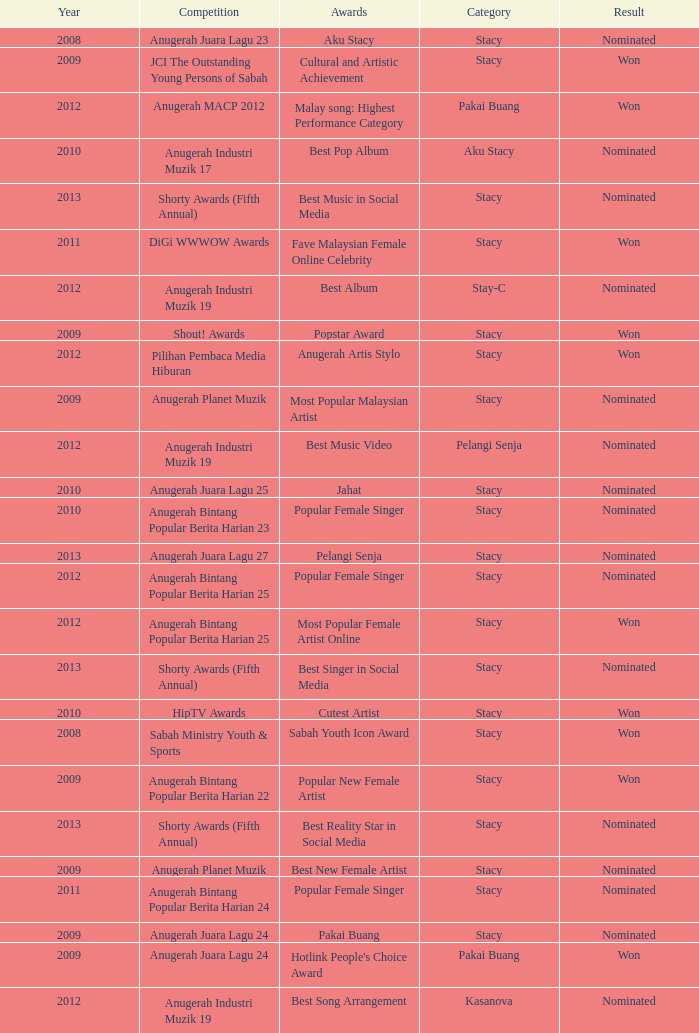What year has Stacy as the category and award of Best Reality Star in Social Media? 2013.0. 